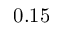<formula> <loc_0><loc_0><loc_500><loc_500>0 . 1 5</formula> 